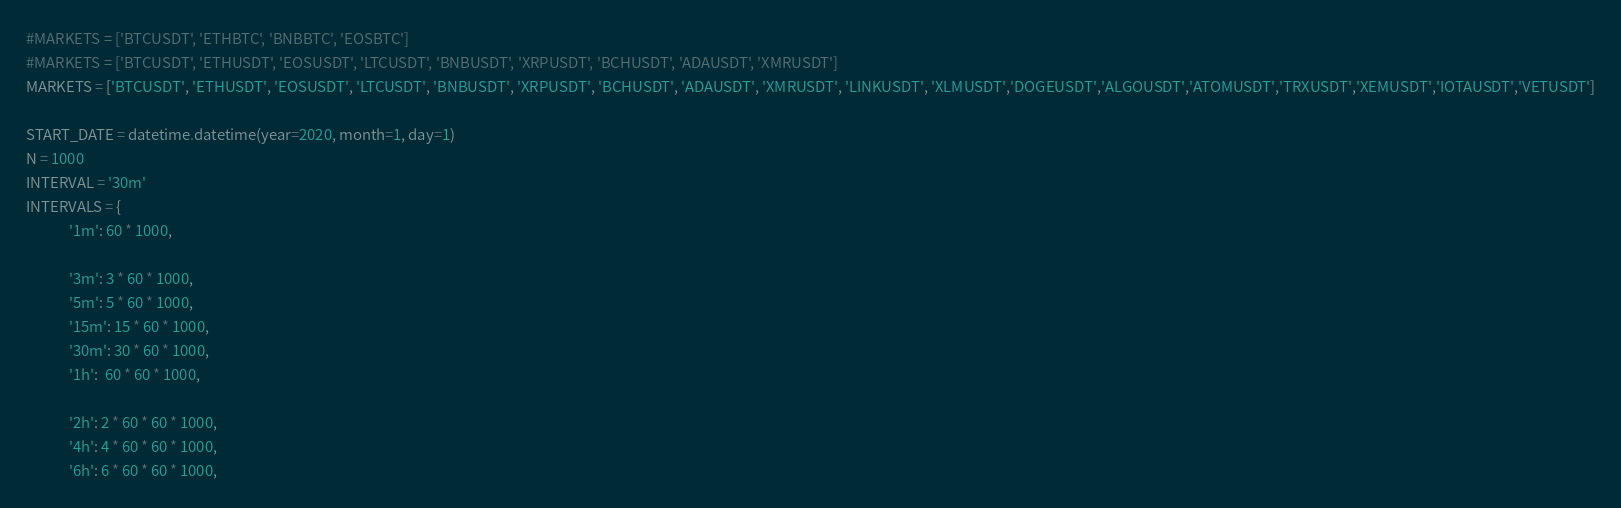Convert code to text. <code><loc_0><loc_0><loc_500><loc_500><_Python_>
#MARKETS = ['BTCUSDT', 'ETHBTC', 'BNBBTC', 'EOSBTC']
#MARKETS = ['BTCUSDT', 'ETHUSDT', 'EOSUSDT', 'LTCUSDT', 'BNBUSDT', 'XRPUSDT', 'BCHUSDT', 'ADAUSDT', 'XMRUSDT']
MARKETS = ['BTCUSDT', 'ETHUSDT', 'EOSUSDT', 'LTCUSDT', 'BNBUSDT', 'XRPUSDT', 'BCHUSDT', 'ADAUSDT', 'XMRUSDT', 'LINKUSDT', 'XLMUSDT','DOGEUSDT','ALGOUSDT','ATOMUSDT','TRXUSDT','XEMUSDT','IOTAUSDT','VETUSDT']

START_DATE = datetime.datetime(year=2020, month=1, day=1)
N = 1000
INTERVAL = '30m'
INTERVALS = {
			 '1m': 60 * 1000,

			 '3m': 3 * 60 * 1000,
			 '5m': 5 * 60 * 1000,
			 '15m': 15 * 60 * 1000,
			 '30m': 30 * 60 * 1000,
			 '1h':  60 * 60 * 1000,

			 '2h': 2 * 60 * 60 * 1000,
			 '4h': 4 * 60 * 60 * 1000,
			 '6h': 6 * 60 * 60 * 1000,</code> 